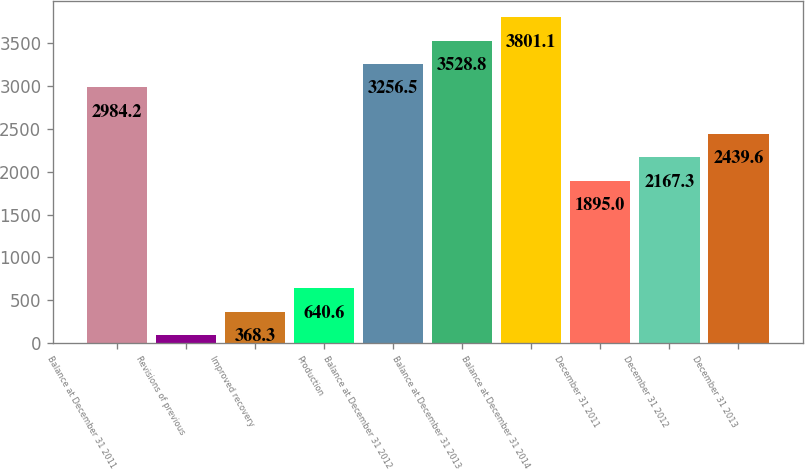Convert chart. <chart><loc_0><loc_0><loc_500><loc_500><bar_chart><fcel>Balance at December 31 2011<fcel>Revisions of previous<fcel>Improved recovery<fcel>Production<fcel>Balance at December 31 2012<fcel>Balance at December 31 2013<fcel>Balance at December 31 2014<fcel>December 31 2011<fcel>December 31 2012<fcel>December 31 2013<nl><fcel>2984.2<fcel>96<fcel>368.3<fcel>640.6<fcel>3256.5<fcel>3528.8<fcel>3801.1<fcel>1895<fcel>2167.3<fcel>2439.6<nl></chart> 